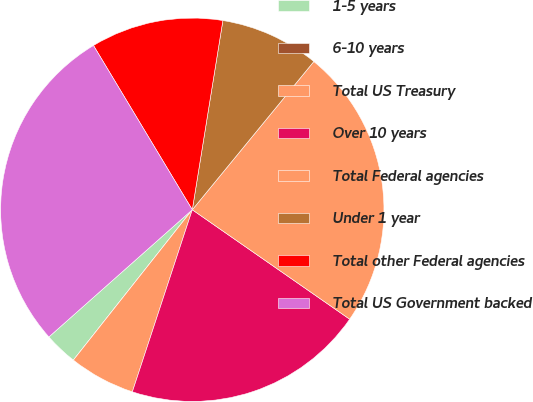Convert chart. <chart><loc_0><loc_0><loc_500><loc_500><pie_chart><fcel>1-5 years<fcel>6-10 years<fcel>Total US Treasury<fcel>Over 10 years<fcel>Total Federal agencies<fcel>Under 1 year<fcel>Total other Federal agencies<fcel>Total US Government backed<nl><fcel>2.8%<fcel>0.0%<fcel>5.59%<fcel>20.39%<fcel>23.74%<fcel>8.38%<fcel>11.17%<fcel>27.93%<nl></chart> 